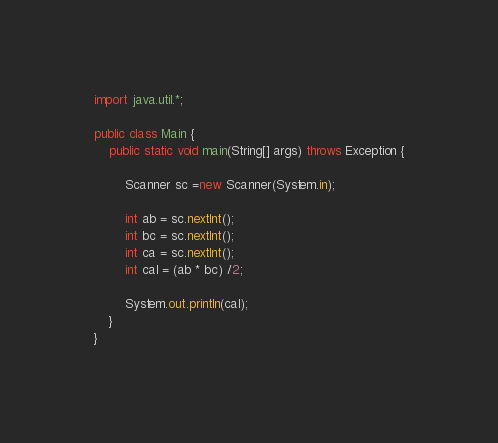<code> <loc_0><loc_0><loc_500><loc_500><_Java_>import java.util.*;

public class Main {
    public static void main(String[] args) throws Exception {
        
        Scanner sc =new Scanner(System.in);
        
        int ab = sc.nextInt();
        int bc = sc.nextInt();
        int ca = sc.nextInt();
        int cal = (ab * bc) /2;

        System.out.println(cal);
    }
}
</code> 